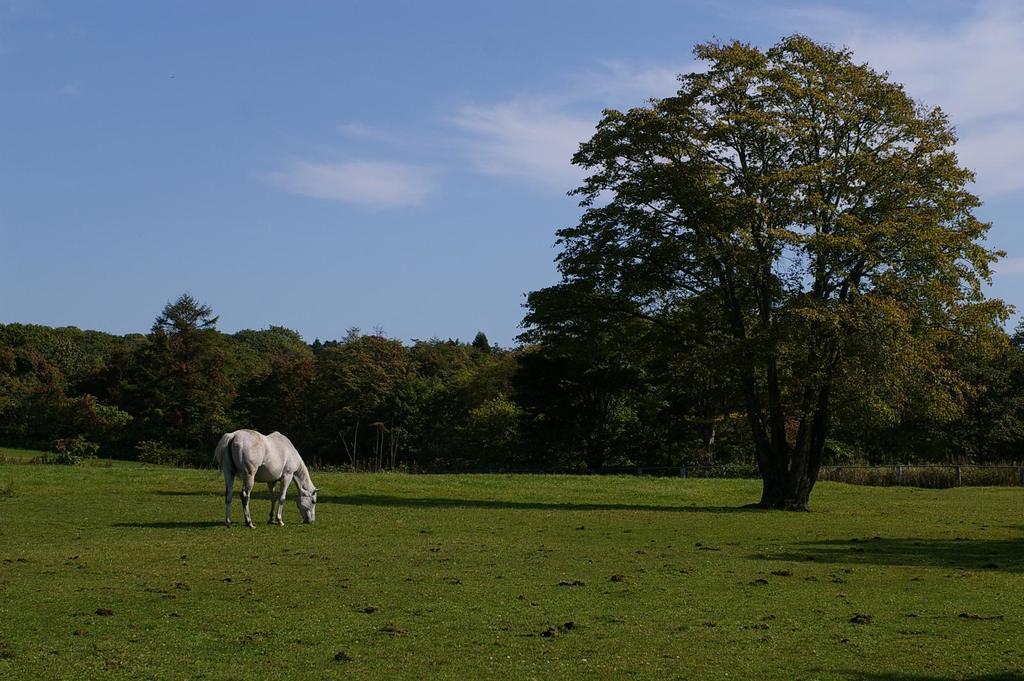Describe this image in one or two sentences. In the image there is a horse standing on the ground. On the ground there is grass and also there is a tree. In the background there are trees. At the top of the image there is sky with clouds. 